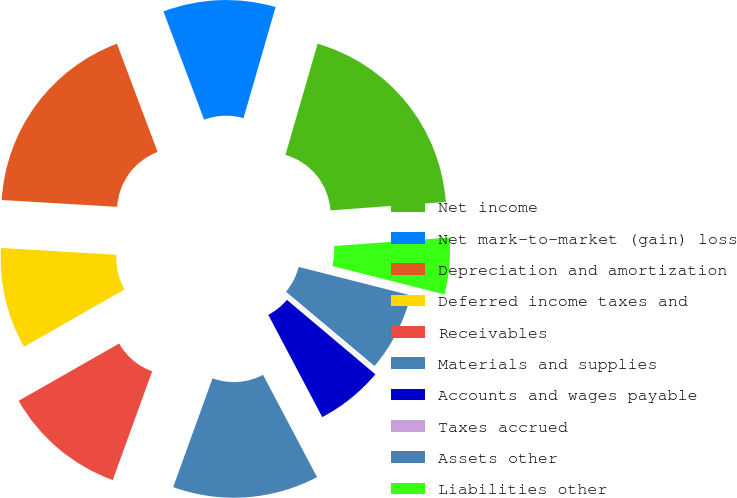Convert chart to OTSL. <chart><loc_0><loc_0><loc_500><loc_500><pie_chart><fcel>Net income<fcel>Net mark-to-market (gain) loss<fcel>Depreciation and amortization<fcel>Deferred income taxes and<fcel>Receivables<fcel>Materials and supplies<fcel>Accounts and wages payable<fcel>Taxes accrued<fcel>Assets other<fcel>Liabilities other<nl><fcel>19.36%<fcel>10.2%<fcel>18.34%<fcel>9.19%<fcel>11.22%<fcel>13.26%<fcel>6.13%<fcel>0.03%<fcel>7.15%<fcel>5.12%<nl></chart> 